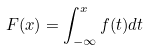Convert formula to latex. <formula><loc_0><loc_0><loc_500><loc_500>F ( x ) = \int _ { - \infty } ^ { x } f ( t ) d t</formula> 